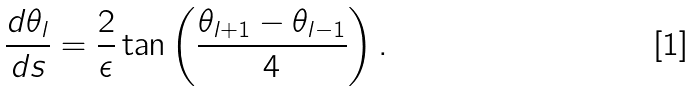Convert formula to latex. <formula><loc_0><loc_0><loc_500><loc_500>\frac { d \theta _ { l } } { d s } = \frac { 2 } { \epsilon } \tan \left ( \frac { \theta _ { l + 1 } - \theta _ { l - 1 } } { 4 } \right ) .</formula> 